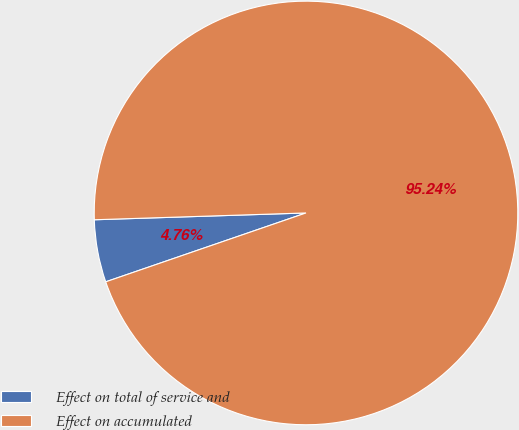<chart> <loc_0><loc_0><loc_500><loc_500><pie_chart><fcel>Effect on total of service and<fcel>Effect on accumulated<nl><fcel>4.76%<fcel>95.24%<nl></chart> 